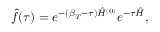Convert formula to latex. <formula><loc_0><loc_0><loc_500><loc_500>\hat { f } ( \tau ) = e ^ { - ( \beta _ { T } - \tau ) \hat { H } ^ { ( 0 ) } } e ^ { - \tau \hat { H } } ,</formula> 